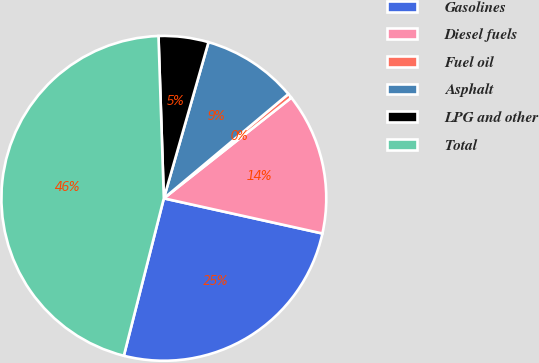Convert chart. <chart><loc_0><loc_0><loc_500><loc_500><pie_chart><fcel>Gasolines<fcel>Diesel fuels<fcel>Fuel oil<fcel>Asphalt<fcel>LPG and other<fcel>Total<nl><fcel>25.49%<fcel>14.11%<fcel>0.46%<fcel>9.47%<fcel>4.96%<fcel>45.52%<nl></chart> 